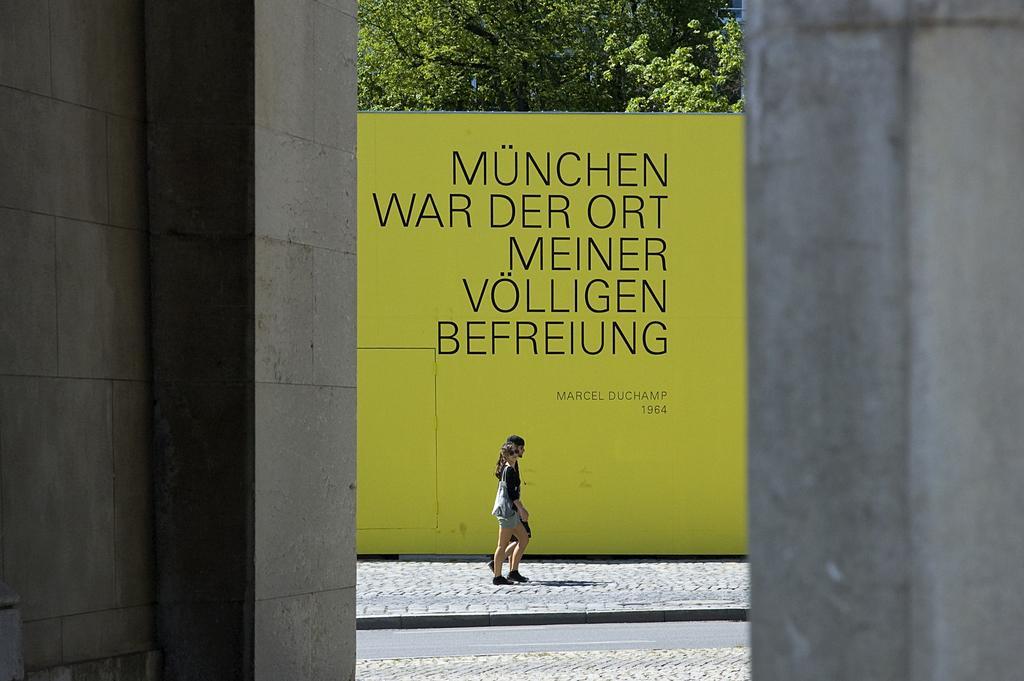How would you summarize this image in a sentence or two? In this image there is a lady walking on the pavement, behind them there is a display board, behind the display board there are trees. 